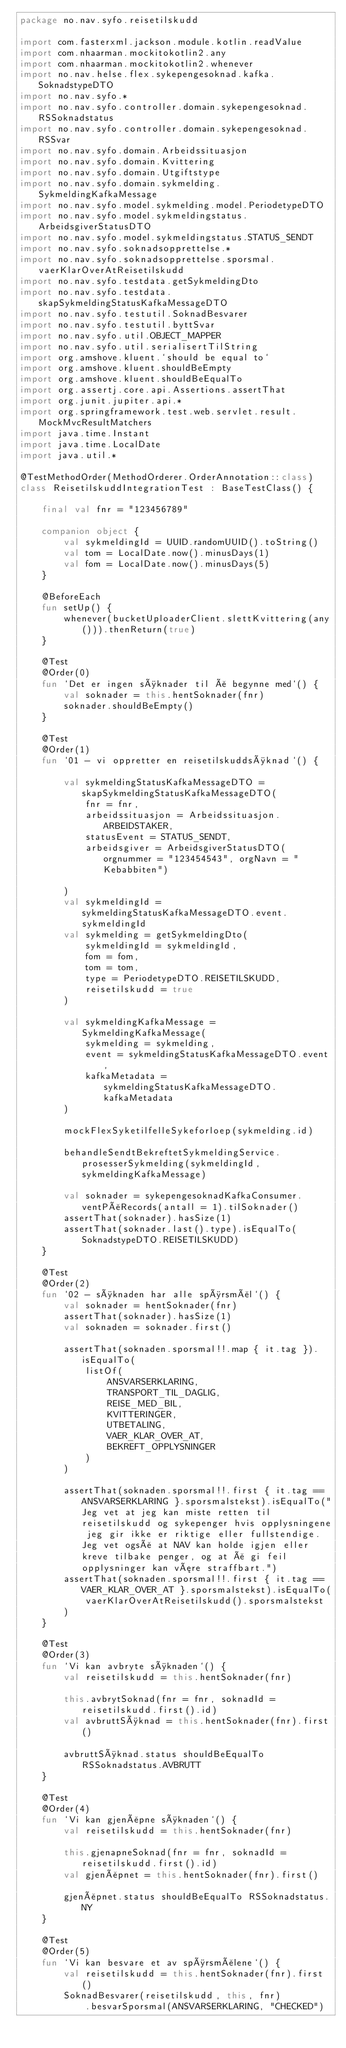Convert code to text. <code><loc_0><loc_0><loc_500><loc_500><_Kotlin_>package no.nav.syfo.reisetilskudd

import com.fasterxml.jackson.module.kotlin.readValue
import com.nhaarman.mockitokotlin2.any
import com.nhaarman.mockitokotlin2.whenever
import no.nav.helse.flex.sykepengesoknad.kafka.SoknadstypeDTO
import no.nav.syfo.*
import no.nav.syfo.controller.domain.sykepengesoknad.RSSoknadstatus
import no.nav.syfo.controller.domain.sykepengesoknad.RSSvar
import no.nav.syfo.domain.Arbeidssituasjon
import no.nav.syfo.domain.Kvittering
import no.nav.syfo.domain.Utgiftstype
import no.nav.syfo.domain.sykmelding.SykmeldingKafkaMessage
import no.nav.syfo.model.sykmelding.model.PeriodetypeDTO
import no.nav.syfo.model.sykmeldingstatus.ArbeidsgiverStatusDTO
import no.nav.syfo.model.sykmeldingstatus.STATUS_SENDT
import no.nav.syfo.soknadsopprettelse.*
import no.nav.syfo.soknadsopprettelse.sporsmal.vaerKlarOverAtReisetilskudd
import no.nav.syfo.testdata.getSykmeldingDto
import no.nav.syfo.testdata.skapSykmeldingStatusKafkaMessageDTO
import no.nav.syfo.testutil.SoknadBesvarer
import no.nav.syfo.testutil.byttSvar
import no.nav.syfo.util.OBJECT_MAPPER
import no.nav.syfo.util.serialisertTilString
import org.amshove.kluent.`should be equal to`
import org.amshove.kluent.shouldBeEmpty
import org.amshove.kluent.shouldBeEqualTo
import org.assertj.core.api.Assertions.assertThat
import org.junit.jupiter.api.*
import org.springframework.test.web.servlet.result.MockMvcResultMatchers
import java.time.Instant
import java.time.LocalDate
import java.util.*

@TestMethodOrder(MethodOrderer.OrderAnnotation::class)
class ReisetilskuddIntegrationTest : BaseTestClass() {

    final val fnr = "123456789"

    companion object {
        val sykmeldingId = UUID.randomUUID().toString()
        val tom = LocalDate.now().minusDays(1)
        val fom = LocalDate.now().minusDays(5)
    }

    @BeforeEach
    fun setUp() {
        whenever(bucketUploaderClient.slettKvittering(any())).thenReturn(true)
    }

    @Test
    @Order(0)
    fun `Det er ingen søknader til å begynne med`() {
        val soknader = this.hentSoknader(fnr)
        soknader.shouldBeEmpty()
    }

    @Test
    @Order(1)
    fun `01 - vi oppretter en reisetilskuddsøknad`() {

        val sykmeldingStatusKafkaMessageDTO = skapSykmeldingStatusKafkaMessageDTO(
            fnr = fnr,
            arbeidssituasjon = Arbeidssituasjon.ARBEIDSTAKER,
            statusEvent = STATUS_SENDT,
            arbeidsgiver = ArbeidsgiverStatusDTO(orgnummer = "123454543", orgNavn = "Kebabbiten")

        )
        val sykmeldingId = sykmeldingStatusKafkaMessageDTO.event.sykmeldingId
        val sykmelding = getSykmeldingDto(
            sykmeldingId = sykmeldingId,
            fom = fom,
            tom = tom,
            type = PeriodetypeDTO.REISETILSKUDD,
            reisetilskudd = true
        )

        val sykmeldingKafkaMessage = SykmeldingKafkaMessage(
            sykmelding = sykmelding,
            event = sykmeldingStatusKafkaMessageDTO.event,
            kafkaMetadata = sykmeldingStatusKafkaMessageDTO.kafkaMetadata
        )

        mockFlexSyketilfelleSykeforloep(sykmelding.id)

        behandleSendtBekreftetSykmeldingService.prosesserSykmelding(sykmeldingId, sykmeldingKafkaMessage)

        val soknader = sykepengesoknadKafkaConsumer.ventPåRecords(antall = 1).tilSoknader()
        assertThat(soknader).hasSize(1)
        assertThat(soknader.last().type).isEqualTo(SoknadstypeDTO.REISETILSKUDD)
    }

    @Test
    @Order(2)
    fun `02 - søknaden har alle spørsmål`() {
        val soknader = hentSoknader(fnr)
        assertThat(soknader).hasSize(1)
        val soknaden = soknader.first()

        assertThat(soknaden.sporsmal!!.map { it.tag }).isEqualTo(
            listOf(
                ANSVARSERKLARING,
                TRANSPORT_TIL_DAGLIG,
                REISE_MED_BIL,
                KVITTERINGER,
                UTBETALING,
                VAER_KLAR_OVER_AT,
                BEKREFT_OPPLYSNINGER
            )
        )

        assertThat(soknaden.sporsmal!!.first { it.tag == ANSVARSERKLARING }.sporsmalstekst).isEqualTo("Jeg vet at jeg kan miste retten til reisetilskudd og sykepenger hvis opplysningene jeg gir ikke er riktige eller fullstendige. Jeg vet også at NAV kan holde igjen eller kreve tilbake penger, og at å gi feil opplysninger kan være straffbart.")
        assertThat(soknaden.sporsmal!!.first { it.tag == VAER_KLAR_OVER_AT }.sporsmalstekst).isEqualTo(
            vaerKlarOverAtReisetilskudd().sporsmalstekst
        )
    }

    @Test
    @Order(3)
    fun `Vi kan avbryte søknaden`() {
        val reisetilskudd = this.hentSoknader(fnr)

        this.avbrytSoknad(fnr = fnr, soknadId = reisetilskudd.first().id)
        val avbruttSøknad = this.hentSoknader(fnr).first()

        avbruttSøknad.status shouldBeEqualTo RSSoknadstatus.AVBRUTT
    }

    @Test
    @Order(4)
    fun `Vi kan gjenåpne søknaden`() {
        val reisetilskudd = this.hentSoknader(fnr)

        this.gjenapneSoknad(fnr = fnr, soknadId = reisetilskudd.first().id)
        val gjenåpnet = this.hentSoknader(fnr).first()

        gjenåpnet.status shouldBeEqualTo RSSoknadstatus.NY
    }

    @Test
    @Order(5)
    fun `Vi kan besvare et av spørsmålene`() {
        val reisetilskudd = this.hentSoknader(fnr).first()
        SoknadBesvarer(reisetilskudd, this, fnr)
            .besvarSporsmal(ANSVARSERKLARING, "CHECKED")
</code> 